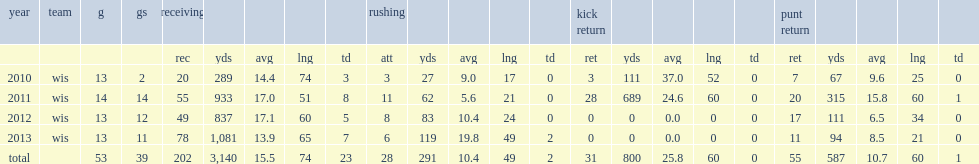How many receiving yards did jared abbrederis get in 2011? 933.0. 